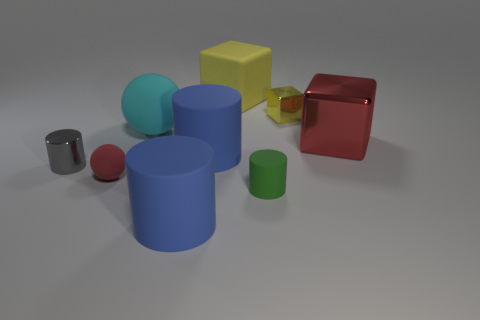Subtract all small gray metallic cylinders. How many cylinders are left? 3 Subtract all yellow cubes. How many cubes are left? 1 Subtract 2 cubes. How many cubes are left? 1 Add 2 large blue metallic blocks. How many large blue metallic blocks exist? 2 Subtract 0 gray spheres. How many objects are left? 9 Subtract all spheres. How many objects are left? 7 Subtract all green cylinders. Subtract all red cubes. How many cylinders are left? 3 Subtract all cyan spheres. How many blue cubes are left? 0 Subtract all big brown metal spheres. Subtract all tiny gray objects. How many objects are left? 8 Add 6 cylinders. How many cylinders are left? 10 